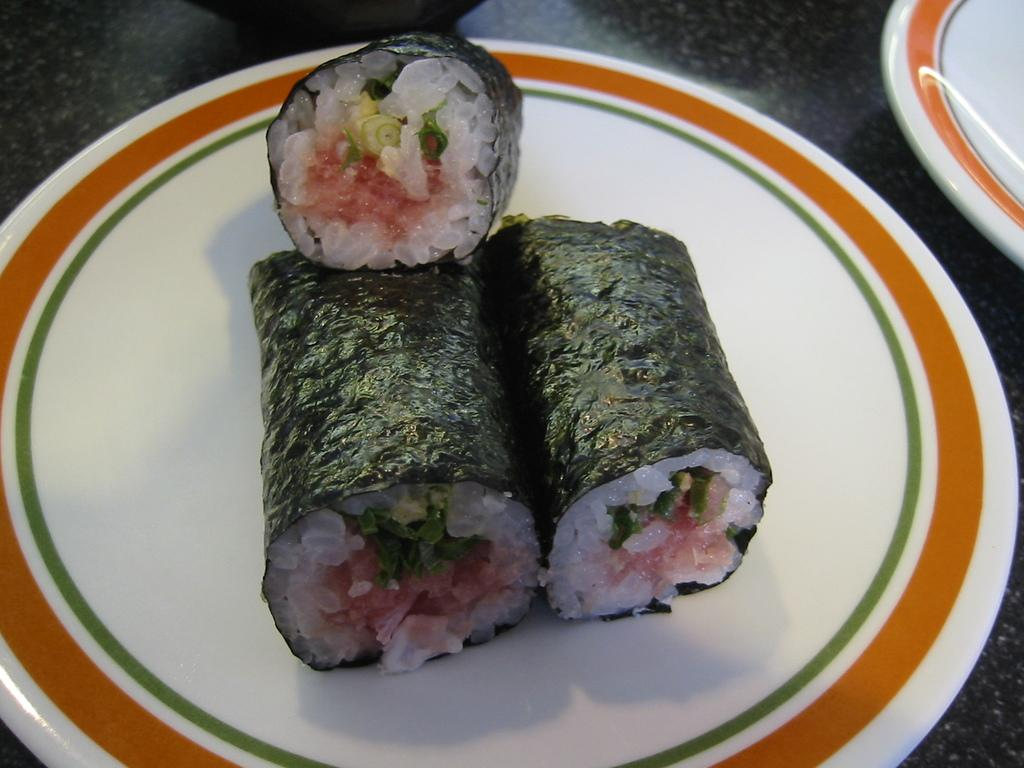What is on the plate that is visible in the image? There is food on a plate in the image. Are there any other plates visible in the image? Yes, there is another plate on the table in the image. What reward is being given to the person in the image? There is no person present in the image, and no reward is being given. How does the food on the plate start cooking in the image? The food on the plate is already cooked and does not require any further cooking. 